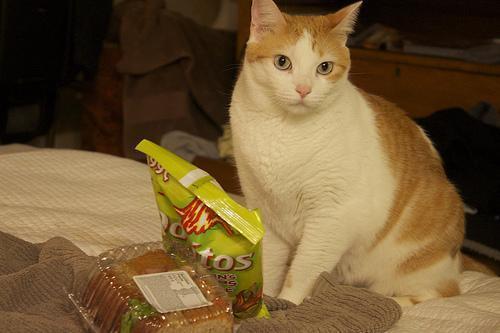How many cats are there?
Give a very brief answer. 1. 